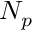<formula> <loc_0><loc_0><loc_500><loc_500>N _ { p }</formula> 